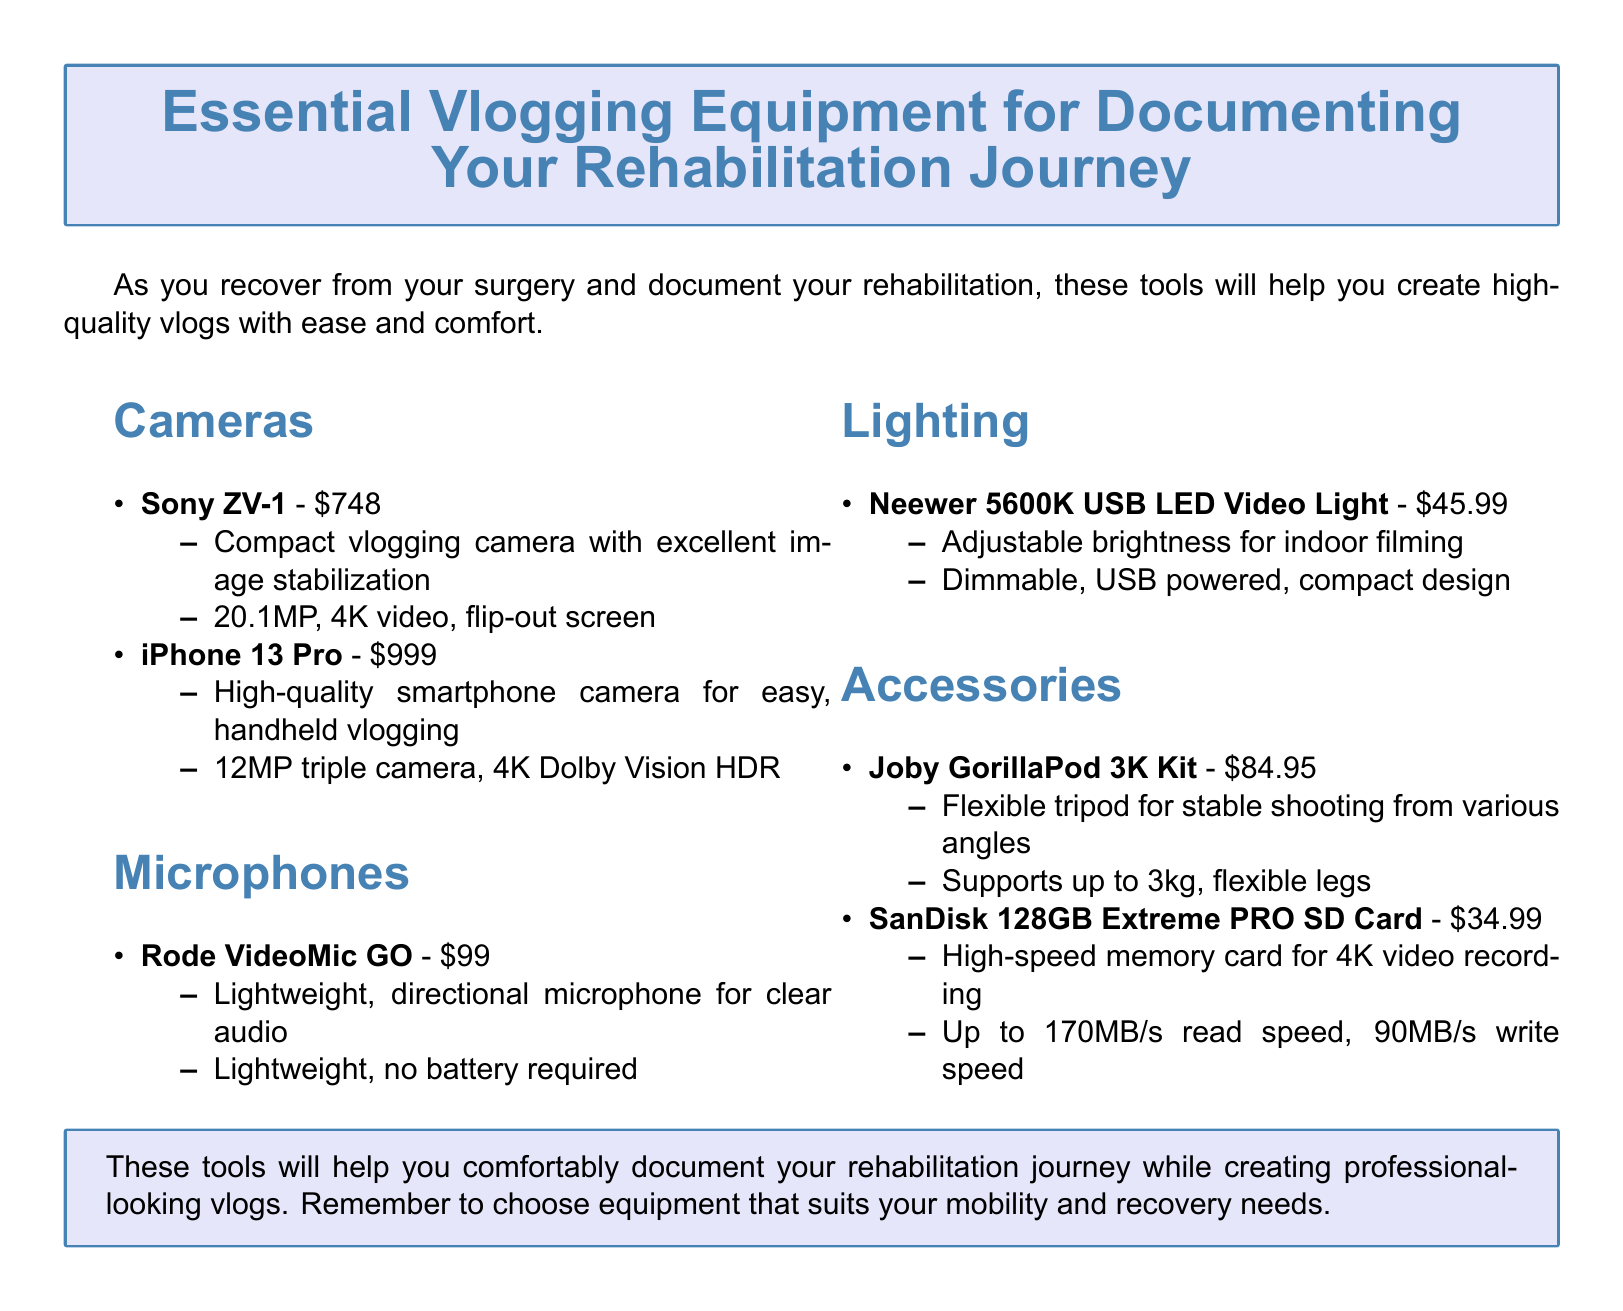What is the price of the Sony ZV-1? The price of the Sony ZV-1 is listed in the document as $748.
Answer: $748 What type of microphone is the Rode VideoMic GO? The Rode VideoMic GO is described as a lightweight, directional microphone for clear audio in the document.
Answer: Lightweight, directional microphone What is the maximum weight the Joby GorillaPod 3K Kit can support? The maximum weight supported by the Joby GorillaPod 3K Kit is mentioned in the document as 3kg.
Answer: 3kg Which smartphone is listed in the catalog? The smartphone mentioned in the catalog is the iPhone 13 Pro.
Answer: iPhone 13 Pro What feature does the Neewer 5600K USB LED Video Light have? The Neewer 5600K USB LED Video Light features adjustable brightness for indoor filming according to the document.
Answer: Adjustable brightness How much does the SanDisk 128GB Extreme PRO SD Card cost? The cost of the SanDisk 128GB Extreme PRO SD Card is stated as $34.99 in the document.
Answer: $34.99 What is the resolution of the Sony ZV-1 camera? The resolution of the Sony ZV-1 camera is indicated in the document as 20.1MP.
Answer: 20.1MP What is the purpose of the Accessories section in the document? The Accessories section is meant to provide additional tools to enhance vlogging quality while documenting rehabilitation.
Answer: Enhance vlogging quality 